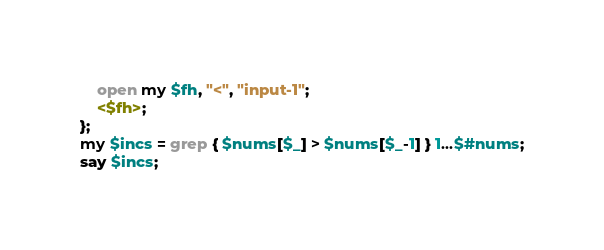Convert code to text. <code><loc_0><loc_0><loc_500><loc_500><_Perl_>    open my $fh, "<", "input-1";
    <$fh>;
};
my $incs = grep { $nums[$_] > $nums[$_-1] } 1...$#nums;
say $incs;
</code> 